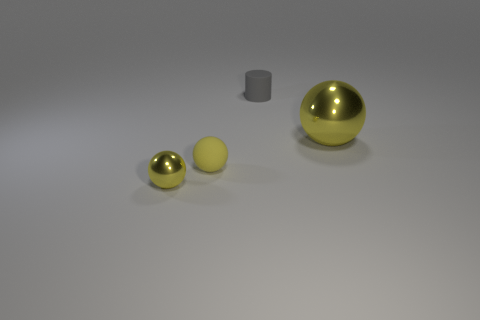Is the yellow object that is right of the small gray matte thing made of the same material as the gray object?
Ensure brevity in your answer.  No. Are there any other things that are the same size as the cylinder?
Provide a succinct answer. Yes. There is a matte sphere; are there any cylinders in front of it?
Ensure brevity in your answer.  No. There is a shiny sphere on the left side of the metallic ball behind the yellow metal ball left of the small gray matte cylinder; what is its color?
Keep it short and to the point. Yellow. The metal thing that is the same size as the yellow rubber thing is what shape?
Your answer should be compact. Sphere. Are there more small metal objects than tiny balls?
Offer a terse response. No. There is a yellow metallic sphere behind the tiny metal object; are there any large yellow objects that are left of it?
Give a very brief answer. No. What is the color of the other metal object that is the same shape as the big shiny object?
Your response must be concise. Yellow. Is there any other thing that has the same shape as the large thing?
Offer a very short reply. Yes. What color is the small object that is made of the same material as the big yellow sphere?
Ensure brevity in your answer.  Yellow. 